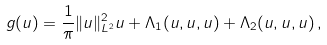<formula> <loc_0><loc_0><loc_500><loc_500>g ( u ) = \frac { 1 } { \pi } \| u \| ^ { 2 } _ { L ^ { 2 } } u + \Lambda _ { 1 } ( u , u , u ) + \Lambda _ { 2 } ( u , u , u ) \, ,</formula> 